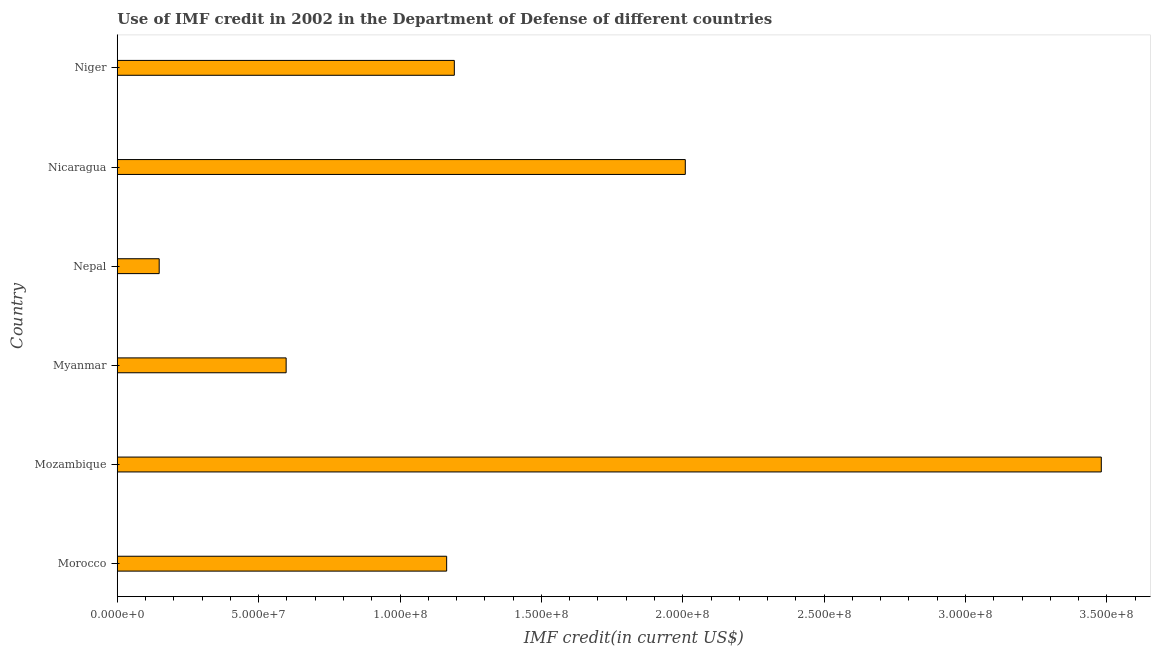What is the title of the graph?
Offer a very short reply. Use of IMF credit in 2002 in the Department of Defense of different countries. What is the label or title of the X-axis?
Keep it short and to the point. IMF credit(in current US$). What is the label or title of the Y-axis?
Ensure brevity in your answer.  Country. What is the use of imf credit in dod in Niger?
Your answer should be compact. 1.19e+08. Across all countries, what is the maximum use of imf credit in dod?
Your response must be concise. 3.48e+08. Across all countries, what is the minimum use of imf credit in dod?
Give a very brief answer. 1.48e+07. In which country was the use of imf credit in dod maximum?
Offer a very short reply. Mozambique. In which country was the use of imf credit in dod minimum?
Ensure brevity in your answer.  Nepal. What is the sum of the use of imf credit in dod?
Your answer should be very brief. 8.59e+08. What is the difference between the use of imf credit in dod in Nepal and Nicaragua?
Offer a very short reply. -1.86e+08. What is the average use of imf credit in dod per country?
Provide a succinct answer. 1.43e+08. What is the median use of imf credit in dod?
Your answer should be compact. 1.18e+08. What is the ratio of the use of imf credit in dod in Nepal to that in Nicaragua?
Offer a very short reply. 0.07. What is the difference between the highest and the second highest use of imf credit in dod?
Provide a short and direct response. 1.47e+08. Is the sum of the use of imf credit in dod in Myanmar and Nicaragua greater than the maximum use of imf credit in dod across all countries?
Your answer should be compact. No. What is the difference between the highest and the lowest use of imf credit in dod?
Your response must be concise. 3.33e+08. How many countries are there in the graph?
Offer a terse response. 6. What is the IMF credit(in current US$) of Morocco?
Ensure brevity in your answer.  1.16e+08. What is the IMF credit(in current US$) of Mozambique?
Ensure brevity in your answer.  3.48e+08. What is the IMF credit(in current US$) in Myanmar?
Keep it short and to the point. 5.97e+07. What is the IMF credit(in current US$) of Nepal?
Provide a short and direct response. 1.48e+07. What is the IMF credit(in current US$) in Nicaragua?
Your answer should be compact. 2.01e+08. What is the IMF credit(in current US$) in Niger?
Make the answer very short. 1.19e+08. What is the difference between the IMF credit(in current US$) in Morocco and Mozambique?
Your answer should be compact. -2.32e+08. What is the difference between the IMF credit(in current US$) in Morocco and Myanmar?
Ensure brevity in your answer.  5.68e+07. What is the difference between the IMF credit(in current US$) in Morocco and Nepal?
Ensure brevity in your answer.  1.02e+08. What is the difference between the IMF credit(in current US$) in Morocco and Nicaragua?
Provide a succinct answer. -8.44e+07. What is the difference between the IMF credit(in current US$) in Morocco and Niger?
Provide a short and direct response. -2.71e+06. What is the difference between the IMF credit(in current US$) in Mozambique and Myanmar?
Your answer should be compact. 2.88e+08. What is the difference between the IMF credit(in current US$) in Mozambique and Nepal?
Keep it short and to the point. 3.33e+08. What is the difference between the IMF credit(in current US$) in Mozambique and Nicaragua?
Your answer should be very brief. 1.47e+08. What is the difference between the IMF credit(in current US$) in Mozambique and Niger?
Provide a succinct answer. 2.29e+08. What is the difference between the IMF credit(in current US$) in Myanmar and Nepal?
Your answer should be very brief. 4.49e+07. What is the difference between the IMF credit(in current US$) in Myanmar and Nicaragua?
Ensure brevity in your answer.  -1.41e+08. What is the difference between the IMF credit(in current US$) in Myanmar and Niger?
Provide a short and direct response. -5.95e+07. What is the difference between the IMF credit(in current US$) in Nepal and Nicaragua?
Offer a very short reply. -1.86e+08. What is the difference between the IMF credit(in current US$) in Nepal and Niger?
Offer a terse response. -1.04e+08. What is the difference between the IMF credit(in current US$) in Nicaragua and Niger?
Offer a terse response. 8.17e+07. What is the ratio of the IMF credit(in current US$) in Morocco to that in Mozambique?
Provide a short and direct response. 0.34. What is the ratio of the IMF credit(in current US$) in Morocco to that in Myanmar?
Your answer should be very brief. 1.95. What is the ratio of the IMF credit(in current US$) in Morocco to that in Nepal?
Offer a terse response. 7.86. What is the ratio of the IMF credit(in current US$) in Morocco to that in Nicaragua?
Ensure brevity in your answer.  0.58. What is the ratio of the IMF credit(in current US$) in Mozambique to that in Myanmar?
Give a very brief answer. 5.83. What is the ratio of the IMF credit(in current US$) in Mozambique to that in Nepal?
Your response must be concise. 23.48. What is the ratio of the IMF credit(in current US$) in Mozambique to that in Nicaragua?
Offer a very short reply. 1.73. What is the ratio of the IMF credit(in current US$) in Mozambique to that in Niger?
Your answer should be compact. 2.92. What is the ratio of the IMF credit(in current US$) in Myanmar to that in Nepal?
Your response must be concise. 4.03. What is the ratio of the IMF credit(in current US$) in Myanmar to that in Nicaragua?
Make the answer very short. 0.3. What is the ratio of the IMF credit(in current US$) in Myanmar to that in Niger?
Ensure brevity in your answer.  0.5. What is the ratio of the IMF credit(in current US$) in Nepal to that in Nicaragua?
Provide a succinct answer. 0.07. What is the ratio of the IMF credit(in current US$) in Nepal to that in Niger?
Your response must be concise. 0.12. What is the ratio of the IMF credit(in current US$) in Nicaragua to that in Niger?
Give a very brief answer. 1.69. 